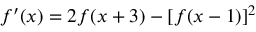<formula> <loc_0><loc_0><loc_500><loc_500>f ^ { \prime } ( x ) = 2 f ( x + 3 ) - [ f ( x - 1 ) ] ^ { 2 }</formula> 